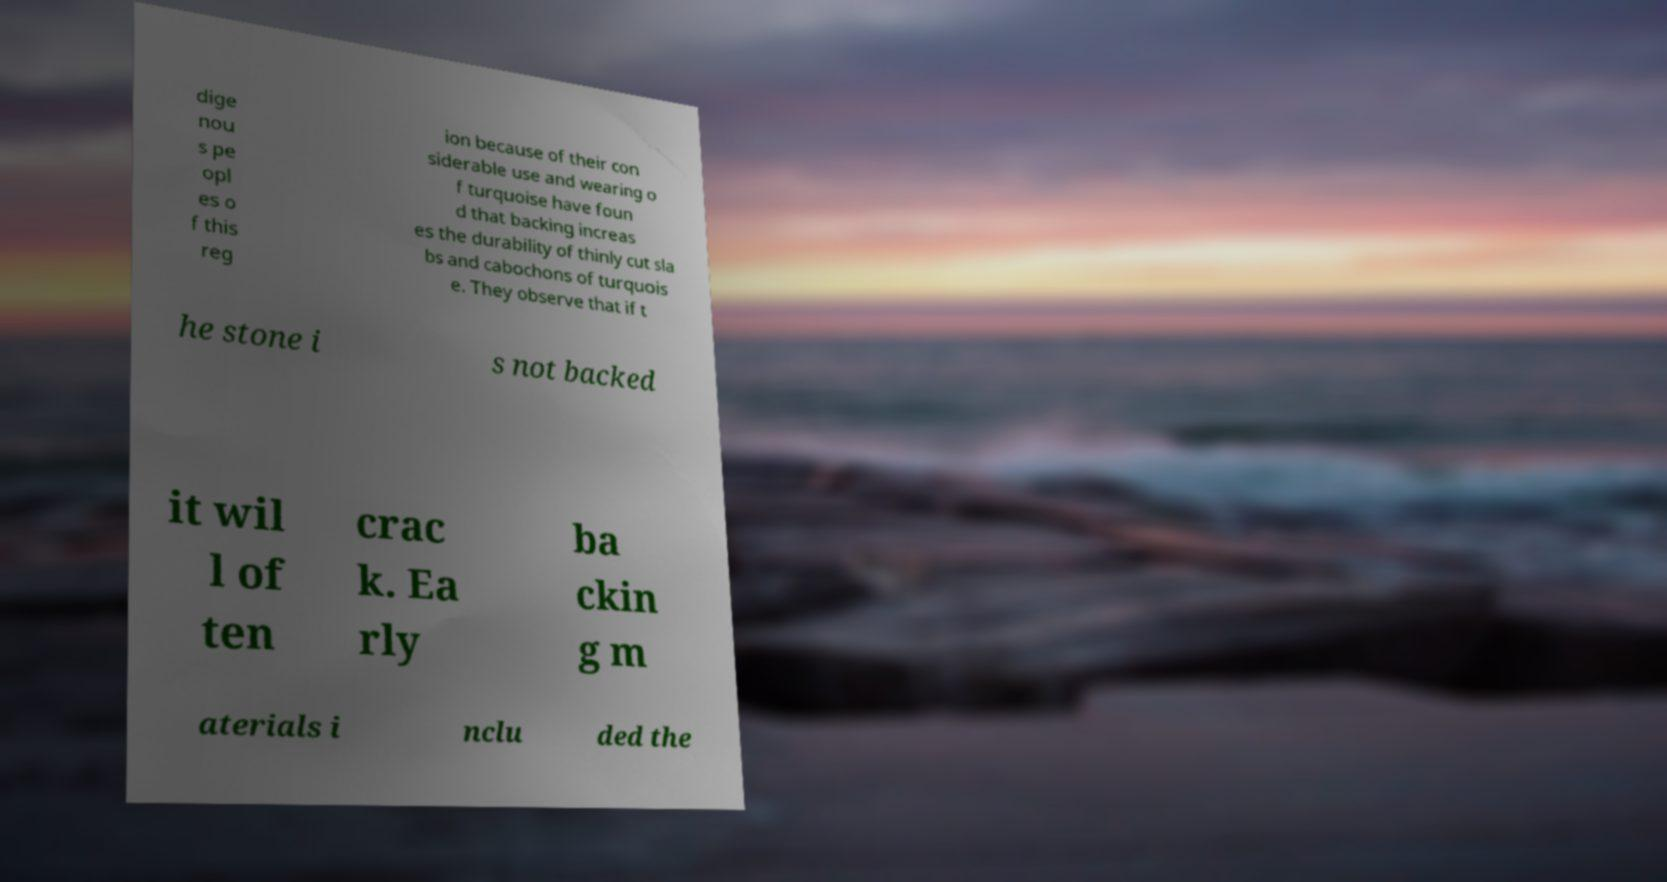Can you read and provide the text displayed in the image?This photo seems to have some interesting text. Can you extract and type it out for me? dige nou s pe opl es o f this reg ion because of their con siderable use and wearing o f turquoise have foun d that backing increas es the durability of thinly cut sla bs and cabochons of turquois e. They observe that if t he stone i s not backed it wil l of ten crac k. Ea rly ba ckin g m aterials i nclu ded the 